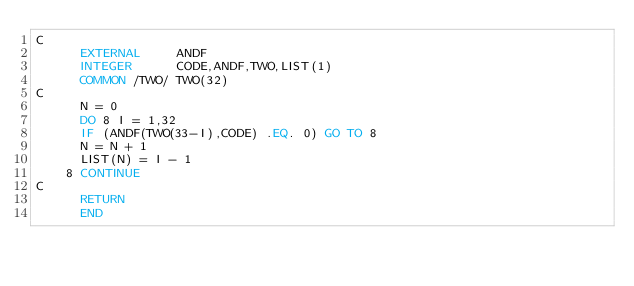Convert code to text. <code><loc_0><loc_0><loc_500><loc_500><_FORTRAN_>C
      EXTERNAL     ANDF
      INTEGER      CODE,ANDF,TWO,LIST(1)
      COMMON /TWO/ TWO(32)
C
      N = 0
      DO 8 I = 1,32
      IF (ANDF(TWO(33-I),CODE) .EQ. 0) GO TO 8
      N = N + 1
      LIST(N) = I - 1
    8 CONTINUE
C
      RETURN
      END
</code> 